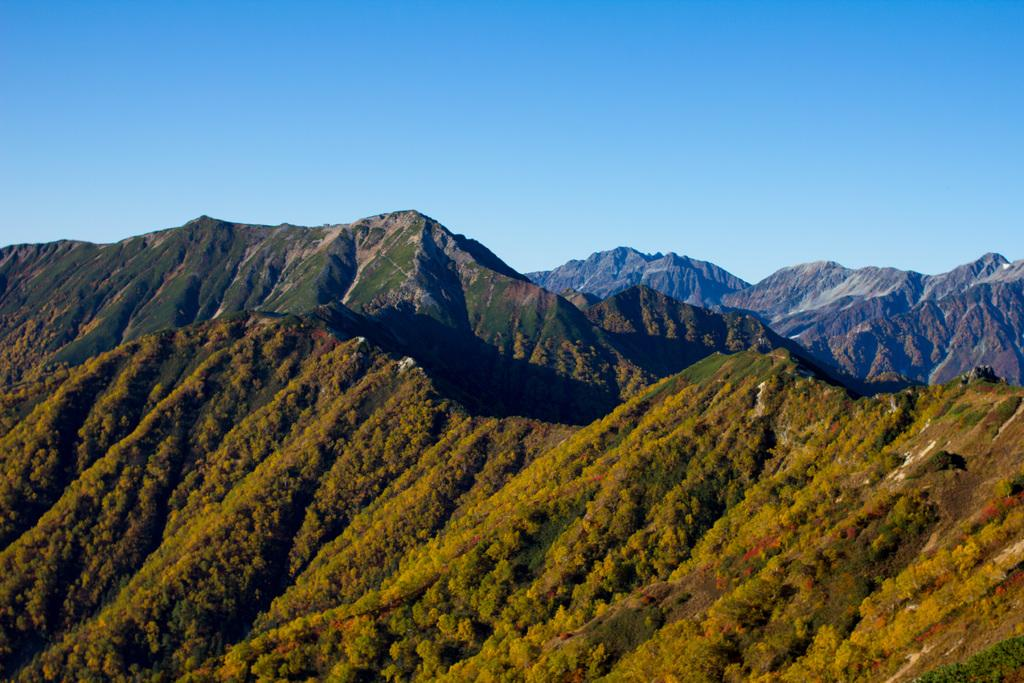What type of natural formation can be seen in the image? The image contains mountains. What is covering the foreground of the mountains? The foreground of the mountains is covered with trees. What is the condition of the sky in the image? The sky is clear in the image. Can you see a swing in the image? No, there is no swing present in the image. Is there a fan visible in the image? No, there is no fan present in the image. 